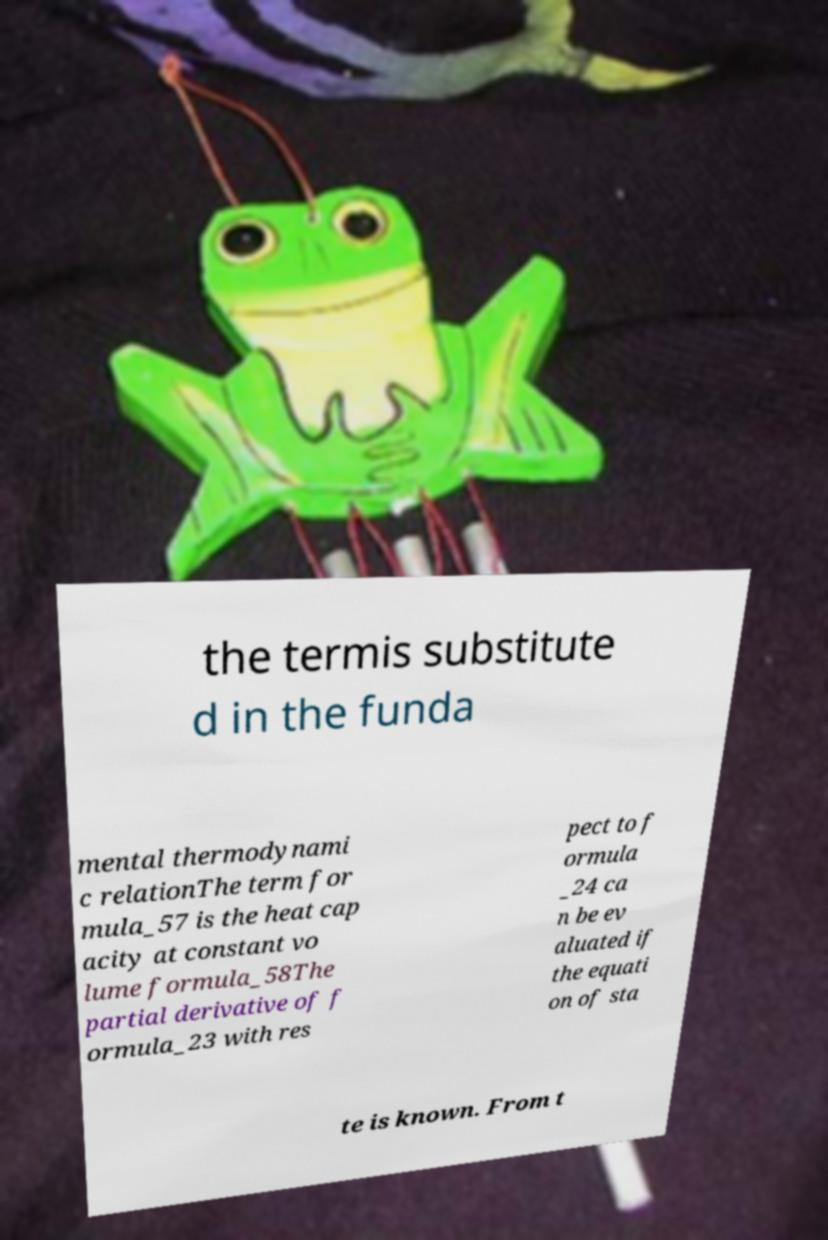There's text embedded in this image that I need extracted. Can you transcribe it verbatim? the termis substitute d in the funda mental thermodynami c relationThe term for mula_57 is the heat cap acity at constant vo lume formula_58The partial derivative of f ormula_23 with res pect to f ormula _24 ca n be ev aluated if the equati on of sta te is known. From t 